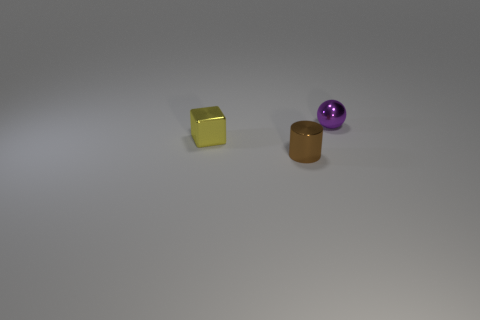Does the object that is in front of the small cube have the same color as the small metal object that is to the left of the small brown metallic cylinder?
Keep it short and to the point. No. Are there any small brown shiny objects?
Ensure brevity in your answer.  Yes. There is a metallic object that is left of the tiny object in front of the yellow block that is behind the tiny cylinder; what is its size?
Keep it short and to the point. Small. There is a tiny yellow object; does it have the same shape as the small metal thing that is on the right side of the brown cylinder?
Your answer should be very brief. No. Are there any small metal spheres that have the same color as the small metal cylinder?
Your response must be concise. No. What number of blocks are either small yellow things or tiny red things?
Provide a short and direct response. 1. Is there a small green thing of the same shape as the small purple metallic object?
Provide a short and direct response. No. Are there fewer tiny yellow metal objects that are behind the purple metal object than brown objects?
Offer a very short reply. Yes. What number of large blue blocks are there?
Make the answer very short. 0. What number of tiny brown cylinders have the same material as the brown object?
Your answer should be compact. 0. 